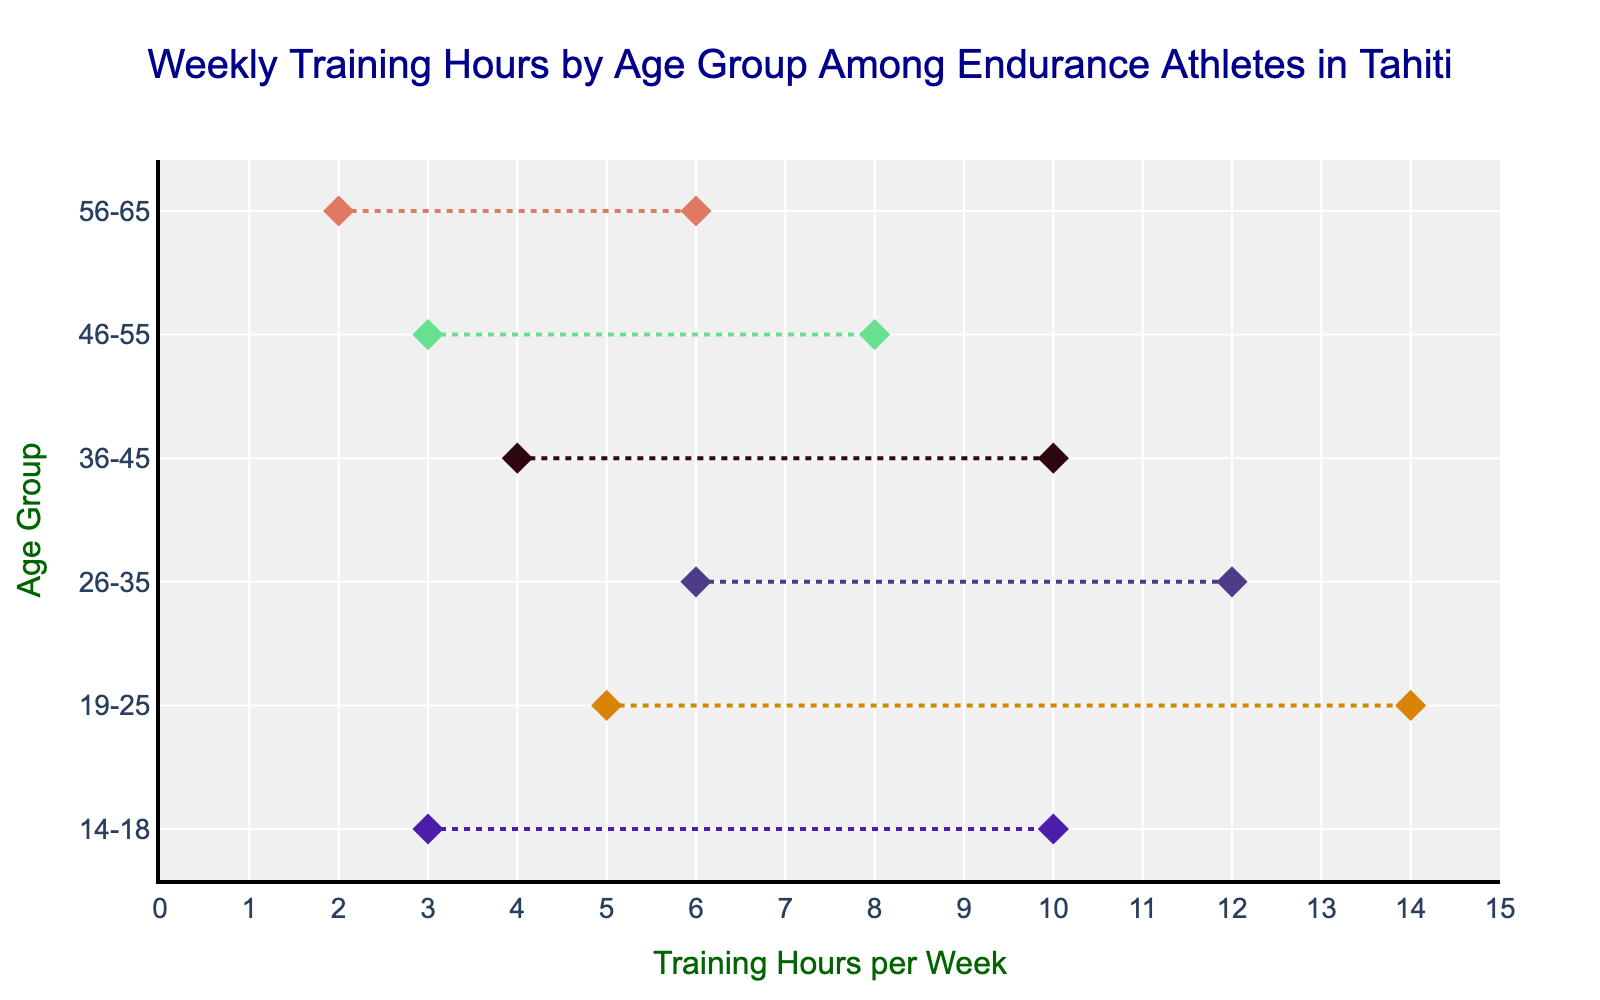What is the minimum training hours for athletes aged 14-18? The minimum training hours for athletes aged 14-18 can be found by looking at the start of the line in the ranged dot plot corresponding to this age group.
Answer: 3 What is the range of weekly training hours for athletes aged 46-55? The range of weekly training hours for athletes aged 46-55 is the difference between the maximum and minimum values indicated by the endpoints of the line for this age group in the plotted figure. The range is 8 - 3.
Answer: 5 Which age group has the highest maximum training hours? To find the age group with the highest maximum training hours, we look at the endpoints of all lines and find the highest value. The highest maximum value is 14 hours, which corresponds to the age group 19-25.
Answer: 19-25 How does the average weekly training hours for age group 26-35 compare to that of 56-65? To compare the average, we calculate it for both groups first by adding the minimum and maximum values and then dividing by 2. For 26-35: (6+12)/2 = 9. For 56-65: (2+6)/2 = 4. Comparing these averages, 9 is greater than 4.
Answer: Higher for 26-35 What is the average weekly training hours for the 36-45 age group? The average weekly training hours can be found by adding the minimum and maximum values and dividing by 2. For the 36-45 age group, (4 + 10) / 2 = 7.
Answer: 7 Which age group has the smallest range of weekly training hours? The smallest range can be determined by finding the difference between the maximum and minimum values for each age group and identifying the smallest difference. For the ranges: 14-18 (7), 19-25 (9), 26-35 (6), 36-45 (6), 46-55 (5), 56-65 (4), the smallest range is 4, corresponding to age group 56-65.
Answer: 56-65 By how many hours do the maximum training hours differ between the age groups 19-25 and 56-65? The maximum training hours for the 19-25 age group is 14, and for 56-65, it is 6. The difference is 14 - 6.
Answer: 8 Which age groups have a minimum training week of 3 hours? We identify the lines that start from 3 hours on the x-axis. The age groups which have 3 hours as their minimum are 14-18 and 46-55.
Answer: 14-18 and 46-55 What is the median of the maximum weekly training hours across all age groups? To find the median, we first list the maximum values: 10, 14, 12, 10, 8, 6. Since there are six values, the median is the average of the third and fourth values in the sorted list (10 + 10) / 2 = 10.
Answer: 10 